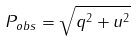Convert formula to latex. <formula><loc_0><loc_0><loc_500><loc_500>P _ { o b s } = \sqrt { q ^ { 2 } + u ^ { 2 } }</formula> 